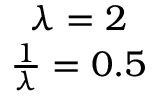Convert formula to latex. <formula><loc_0><loc_0><loc_500><loc_500>\begin{array} { c } { \lambda = 2 } \\ { \frac { 1 } { \lambda } = 0 . 5 } \end{array}</formula> 